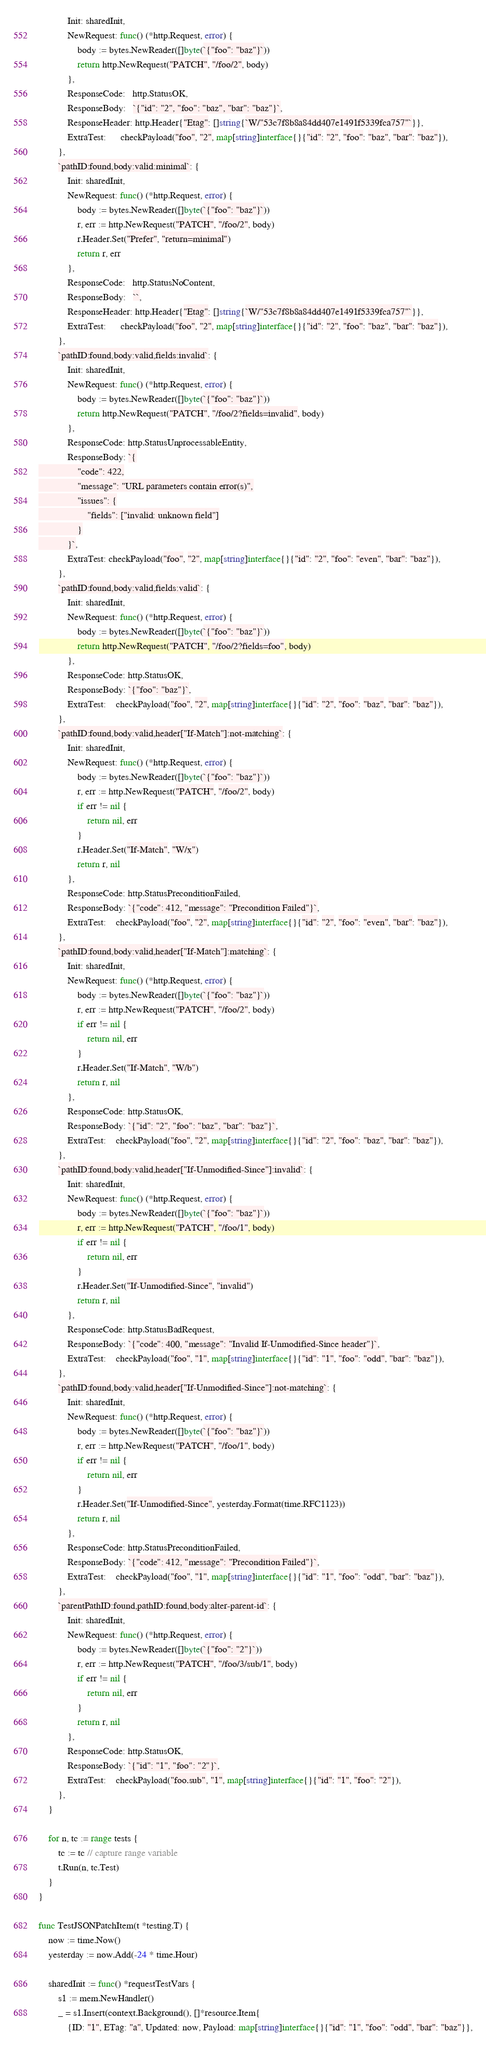Convert code to text. <code><loc_0><loc_0><loc_500><loc_500><_Go_>			Init: sharedInit,
			NewRequest: func() (*http.Request, error) {
				body := bytes.NewReader([]byte(`{"foo": "baz"}`))
				return http.NewRequest("PATCH", "/foo/2", body)
			},
			ResponseCode:   http.StatusOK,
			ResponseBody:   `{"id": "2", "foo": "baz", "bar": "baz"}`,
			ResponseHeader: http.Header{"Etag": []string{`W/"53c7f8b8a84dd407e1491f5339fca757"`}},
			ExtraTest:      checkPayload("foo", "2", map[string]interface{}{"id": "2", "foo": "baz", "bar": "baz"}),
		},
		`pathID:found,body:valid:minimal`: {
			Init: sharedInit,
			NewRequest: func() (*http.Request, error) {
				body := bytes.NewReader([]byte(`{"foo": "baz"}`))
				r, err := http.NewRequest("PATCH", "/foo/2", body)
				r.Header.Set("Prefer", "return=minimal")
				return r, err
			},
			ResponseCode:   http.StatusNoContent,
			ResponseBody:   ``,
			ResponseHeader: http.Header{"Etag": []string{`W/"53c7f8b8a84dd407e1491f5339fca757"`}},
			ExtraTest:      checkPayload("foo", "2", map[string]interface{}{"id": "2", "foo": "baz", "bar": "baz"}),
		},
		`pathID:found,body:valid,fields:invalid`: {
			Init: sharedInit,
			NewRequest: func() (*http.Request, error) {
				body := bytes.NewReader([]byte(`{"foo": "baz"}`))
				return http.NewRequest("PATCH", "/foo/2?fields=invalid", body)
			},
			ResponseCode: http.StatusUnprocessableEntity,
			ResponseBody: `{
				"code": 422,
				"message": "URL parameters contain error(s)",
				"issues": {
					"fields": ["invalid: unknown field"]
				}
			}`,
			ExtraTest: checkPayload("foo", "2", map[string]interface{}{"id": "2", "foo": "even", "bar": "baz"}),
		},
		`pathID:found,body:valid,fields:valid`: {
			Init: sharedInit,
			NewRequest: func() (*http.Request, error) {
				body := bytes.NewReader([]byte(`{"foo": "baz"}`))
				return http.NewRequest("PATCH", "/foo/2?fields=foo", body)
			},
			ResponseCode: http.StatusOK,
			ResponseBody: `{"foo": "baz"}`,
			ExtraTest:    checkPayload("foo", "2", map[string]interface{}{"id": "2", "foo": "baz", "bar": "baz"}),
		},
		`pathID:found,body:valid,header["If-Match"]:not-matching`: {
			Init: sharedInit,
			NewRequest: func() (*http.Request, error) {
				body := bytes.NewReader([]byte(`{"foo": "baz"}`))
				r, err := http.NewRequest("PATCH", "/foo/2", body)
				if err != nil {
					return nil, err
				}
				r.Header.Set("If-Match", "W/x")
				return r, nil
			},
			ResponseCode: http.StatusPreconditionFailed,
			ResponseBody: `{"code": 412, "message": "Precondition Failed"}`,
			ExtraTest:    checkPayload("foo", "2", map[string]interface{}{"id": "2", "foo": "even", "bar": "baz"}),
		},
		`pathID:found,body:valid,header["If-Match"]:matching`: {
			Init: sharedInit,
			NewRequest: func() (*http.Request, error) {
				body := bytes.NewReader([]byte(`{"foo": "baz"}`))
				r, err := http.NewRequest("PATCH", "/foo/2", body)
				if err != nil {
					return nil, err
				}
				r.Header.Set("If-Match", "W/b")
				return r, nil
			},
			ResponseCode: http.StatusOK,
			ResponseBody: `{"id": "2", "foo": "baz", "bar": "baz"}`,
			ExtraTest:    checkPayload("foo", "2", map[string]interface{}{"id": "2", "foo": "baz", "bar": "baz"}),
		},
		`pathID:found,body:valid,header["If-Unmodified-Since"]:invalid`: {
			Init: sharedInit,
			NewRequest: func() (*http.Request, error) {
				body := bytes.NewReader([]byte(`{"foo": "baz"}`))
				r, err := http.NewRequest("PATCH", "/foo/1", body)
				if err != nil {
					return nil, err
				}
				r.Header.Set("If-Unmodified-Since", "invalid")
				return r, nil
			},
			ResponseCode: http.StatusBadRequest,
			ResponseBody: `{"code": 400, "message": "Invalid If-Unmodified-Since header"}`,
			ExtraTest:    checkPayload("foo", "1", map[string]interface{}{"id": "1", "foo": "odd", "bar": "baz"}),
		},
		`pathID:found,body:valid,header["If-Unmodified-Since"]:not-matching`: {
			Init: sharedInit,
			NewRequest: func() (*http.Request, error) {
				body := bytes.NewReader([]byte(`{"foo": "baz"}`))
				r, err := http.NewRequest("PATCH", "/foo/1", body)
				if err != nil {
					return nil, err
				}
				r.Header.Set("If-Unmodified-Since", yesterday.Format(time.RFC1123))
				return r, nil
			},
			ResponseCode: http.StatusPreconditionFailed,
			ResponseBody: `{"code": 412, "message": "Precondition Failed"}`,
			ExtraTest:    checkPayload("foo", "1", map[string]interface{}{"id": "1", "foo": "odd", "bar": "baz"}),
		},
		`parentPathID:found,pathID:found,body:alter-parent-id`: {
			Init: sharedInit,
			NewRequest: func() (*http.Request, error) {
				body := bytes.NewReader([]byte(`{"foo": "2"}`))
				r, err := http.NewRequest("PATCH", "/foo/3/sub/1", body)
				if err != nil {
					return nil, err
				}
				return r, nil
			},
			ResponseCode: http.StatusOK,
			ResponseBody: `{"id": "1", "foo": "2"}`,
			ExtraTest:    checkPayload("foo.sub", "1", map[string]interface{}{"id": "1", "foo": "2"}),
		},
	}

	for n, tc := range tests {
		tc := tc // capture range variable
		t.Run(n, tc.Test)
	}
}

func TestJSONPatchItem(t *testing.T) {
	now := time.Now()
	yesterday := now.Add(-24 * time.Hour)

	sharedInit := func() *requestTestVars {
		s1 := mem.NewHandler()
		_ = s1.Insert(context.Background(), []*resource.Item{
			{ID: "1", ETag: "a", Updated: now, Payload: map[string]interface{}{"id": "1", "foo": "odd", "bar": "baz"}},</code> 